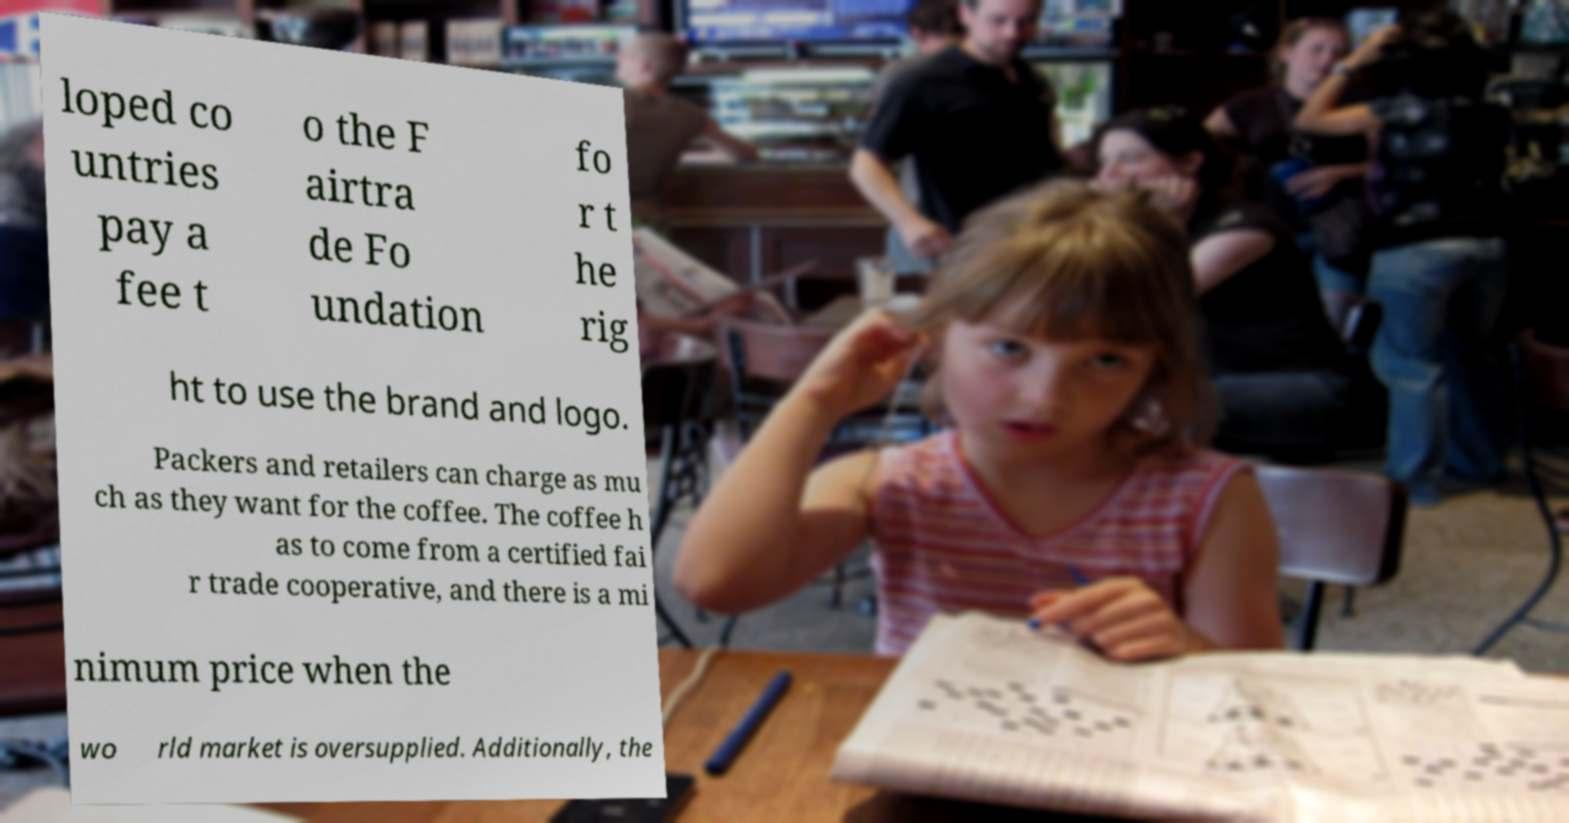There's text embedded in this image that I need extracted. Can you transcribe it verbatim? loped co untries pay a fee t o the F airtra de Fo undation fo r t he rig ht to use the brand and logo. Packers and retailers can charge as mu ch as they want for the coffee. The coffee h as to come from a certified fai r trade cooperative, and there is a mi nimum price when the wo rld market is oversupplied. Additionally, the 